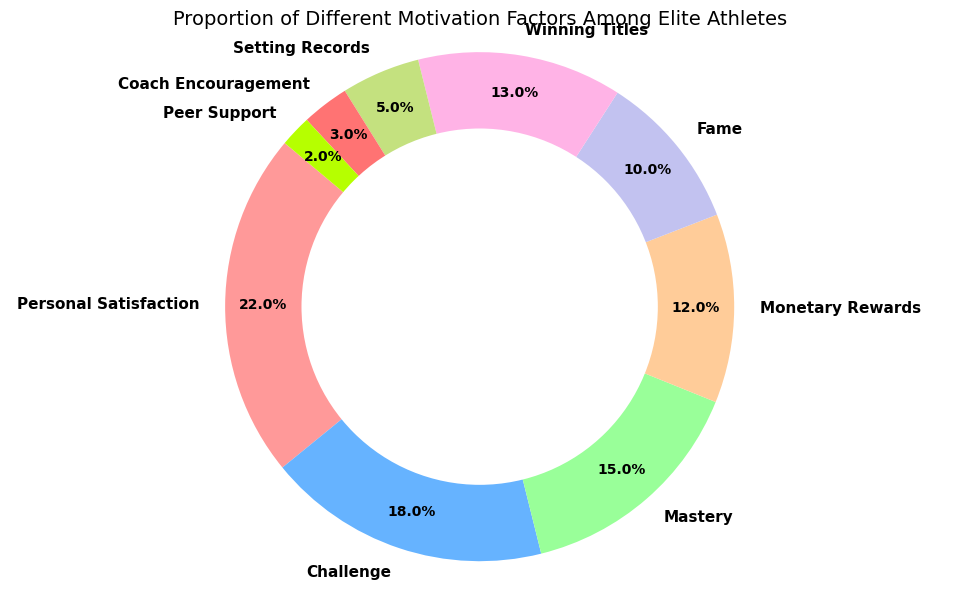Which motivation factor has the highest percentage among elite athletes? The slices of the pie chart representing each motivation factor are labeled with their percentages. Identifying the highest percentage value among them indicates the factor with the highest representation.
Answer: Personal Satisfaction What is the combined percentage of all intrinsic motivation factors? Add up the percentages of Personal Satisfaction (22%), Challenge (18%), and Mastery (15%). Total is 22 + 18 + 15 = 55%.
Answer: 55% How does the percentage of Monetary Rewards compare to Fame? Identify the percentages of the two categories: Monetary Rewards (12%) and Fame (10%). Compare their values to determine the relationship: 12% is higher than 10%.
Answer: Monetary Rewards is higher Which motivation factor related to goal achievement has a higher percentage? There are two factors under Goal Achievement: Winning Titles (13%) and Setting Records (5%). Compare their percentages: 13% is higher than 5%.
Answer: Winning Titles What's the difference between the percentages of the highest and lowest motivation factors? Identify the highest (Personal Satisfaction at 22%) and lowest (Peer Support at 2%) percentages. Calculate the difference: 22% - 2% = 20%.
Answer: 20% What is the percentage of elite athletes motivated by extrinsic factors? Add up the percentages of Monetary Rewards (12%) and Fame (10%). Total is 12 + 10 = 22%.
Answer: 22% How does the sum of Team Support-related factors compare to the sum of Goal Achievement-related factors? Add the percentages of Team Support factors: Coach Encouragement (3%) + Peer Support (2%) = 5%. Add the percentages of Goal Achievement factors: Winning Titles (13%) + Setting Records (5%) = 18%. Compare the sums: 5% vs. 18%.
Answer: Goal Achievement is higher Which factor has a higher percentage: Personal Satisfaction or Winning Titles? Identify the percentages of Personal Satisfaction (22%) and Winning Titles (13%). Compare their values: 22% is higher than 13%.
Answer: Personal Satisfaction 